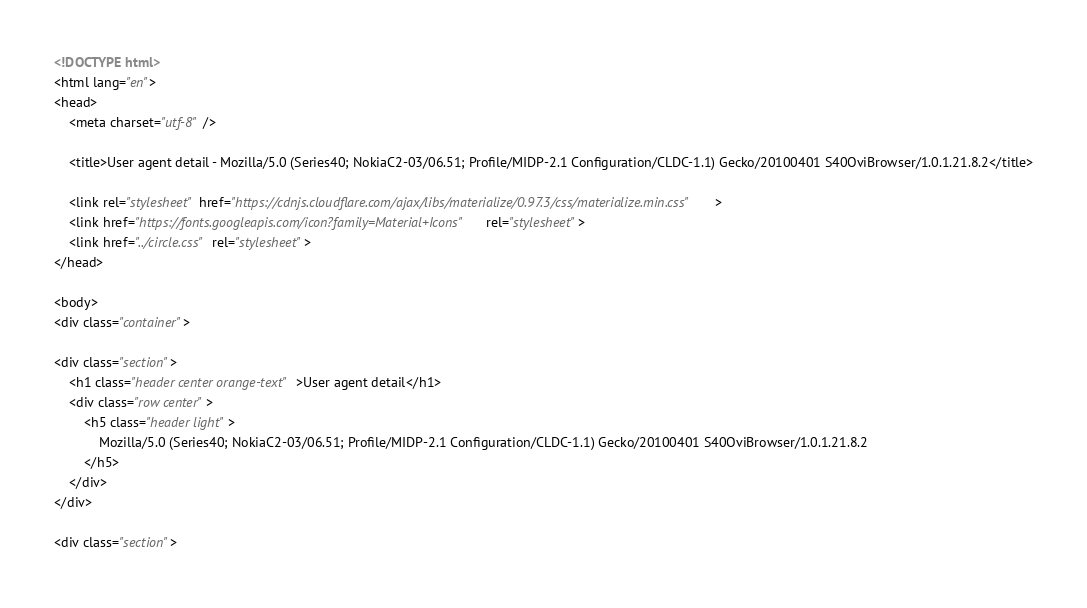<code> <loc_0><loc_0><loc_500><loc_500><_HTML_>
<!DOCTYPE html>
<html lang="en">
<head>
    <meta charset="utf-8" />
            
    <title>User agent detail - Mozilla/5.0 (Series40; NokiaC2-03/06.51; Profile/MIDP-2.1 Configuration/CLDC-1.1) Gecko/20100401 S40OviBrowser/1.0.1.21.8.2</title>
        
    <link rel="stylesheet" href="https://cdnjs.cloudflare.com/ajax/libs/materialize/0.97.3/css/materialize.min.css">
    <link href="https://fonts.googleapis.com/icon?family=Material+Icons" rel="stylesheet">
    <link href="../circle.css" rel="stylesheet">
</head>
        
<body>
<div class="container">
    
<div class="section">
	<h1 class="header center orange-text">User agent detail</h1>
	<div class="row center">
        <h5 class="header light">
            Mozilla/5.0 (Series40; NokiaC2-03/06.51; Profile/MIDP-2.1 Configuration/CLDC-1.1) Gecko/20100401 S40OviBrowser/1.0.1.21.8.2
        </h5>
	</div>
</div>   

<div class="section"></code> 